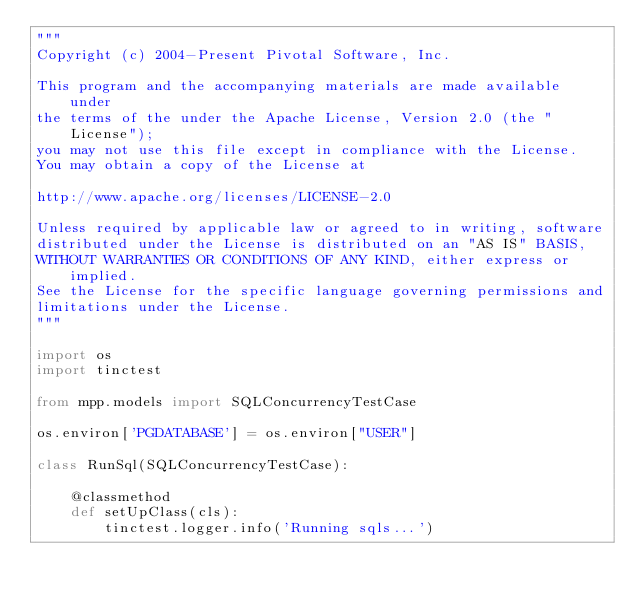<code> <loc_0><loc_0><loc_500><loc_500><_Python_>"""
Copyright (c) 2004-Present Pivotal Software, Inc.

This program and the accompanying materials are made available under
the terms of the under the Apache License, Version 2.0 (the "License");
you may not use this file except in compliance with the License.
You may obtain a copy of the License at

http://www.apache.org/licenses/LICENSE-2.0

Unless required by applicable law or agreed to in writing, software
distributed under the License is distributed on an "AS IS" BASIS,
WITHOUT WARRANTIES OR CONDITIONS OF ANY KIND, either express or implied.
See the License for the specific language governing permissions and
limitations under the License.
"""

import os
import tinctest

from mpp.models import SQLConcurrencyTestCase

os.environ['PGDATABASE'] = os.environ["USER"]

class RunSql(SQLConcurrencyTestCase):

    @classmethod
    def setUpClass(cls):
        tinctest.logger.info('Running sqls...')
</code> 